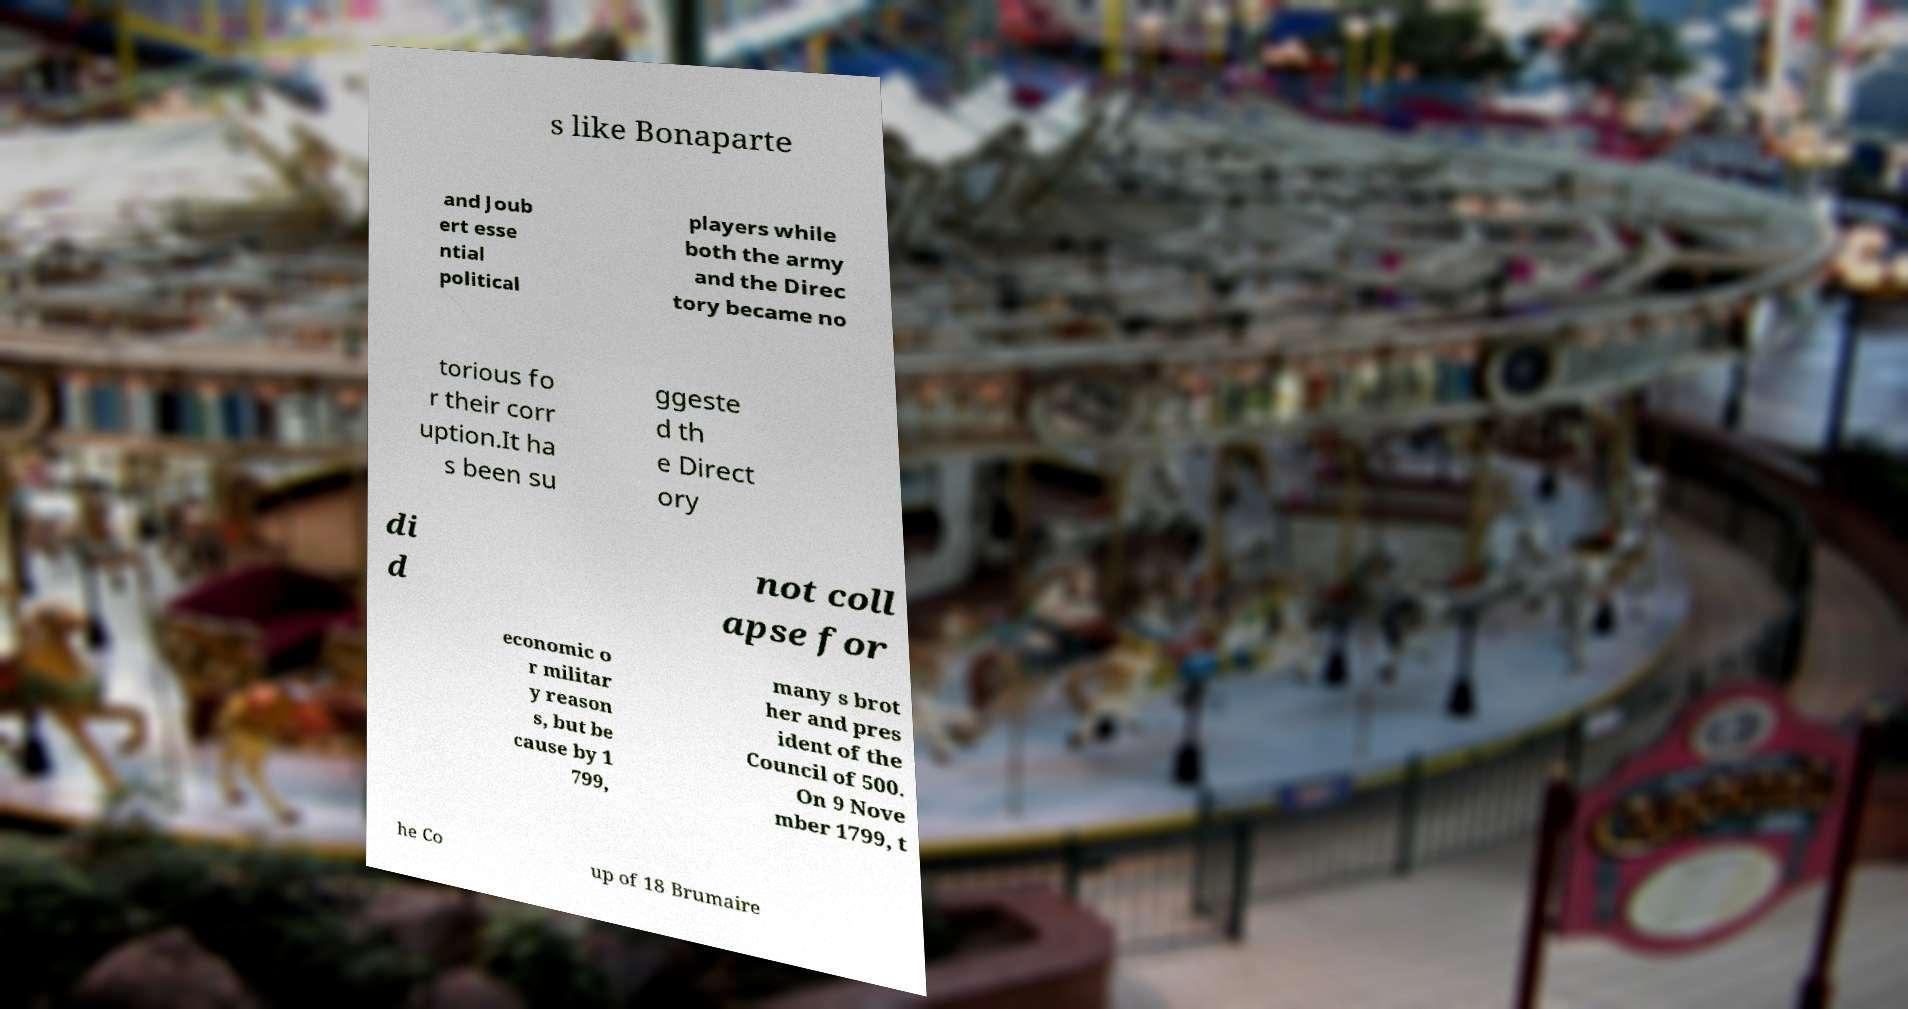Can you accurately transcribe the text from the provided image for me? s like Bonaparte and Joub ert esse ntial political players while both the army and the Direc tory became no torious fo r their corr uption.It ha s been su ggeste d th e Direct ory di d not coll apse for economic o r militar y reason s, but be cause by 1 799, many s brot her and pres ident of the Council of 500. On 9 Nove mber 1799, t he Co up of 18 Brumaire 